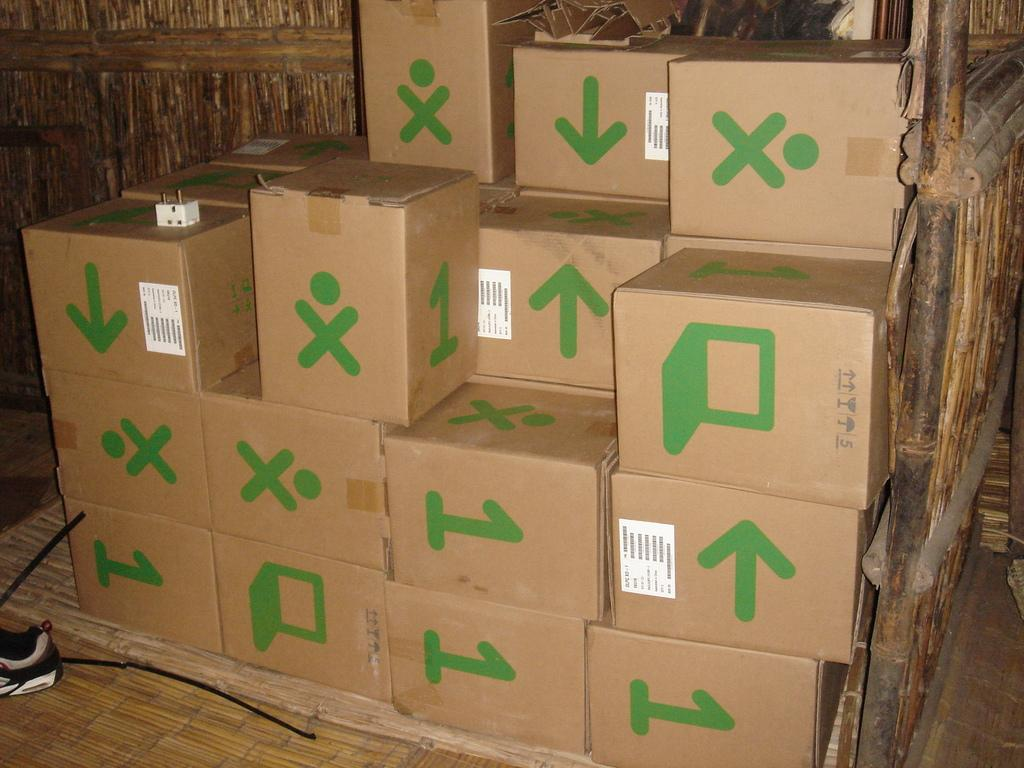<image>
Provide a brief description of the given image. A stack of boxes, some of which have the number 1 on them. 